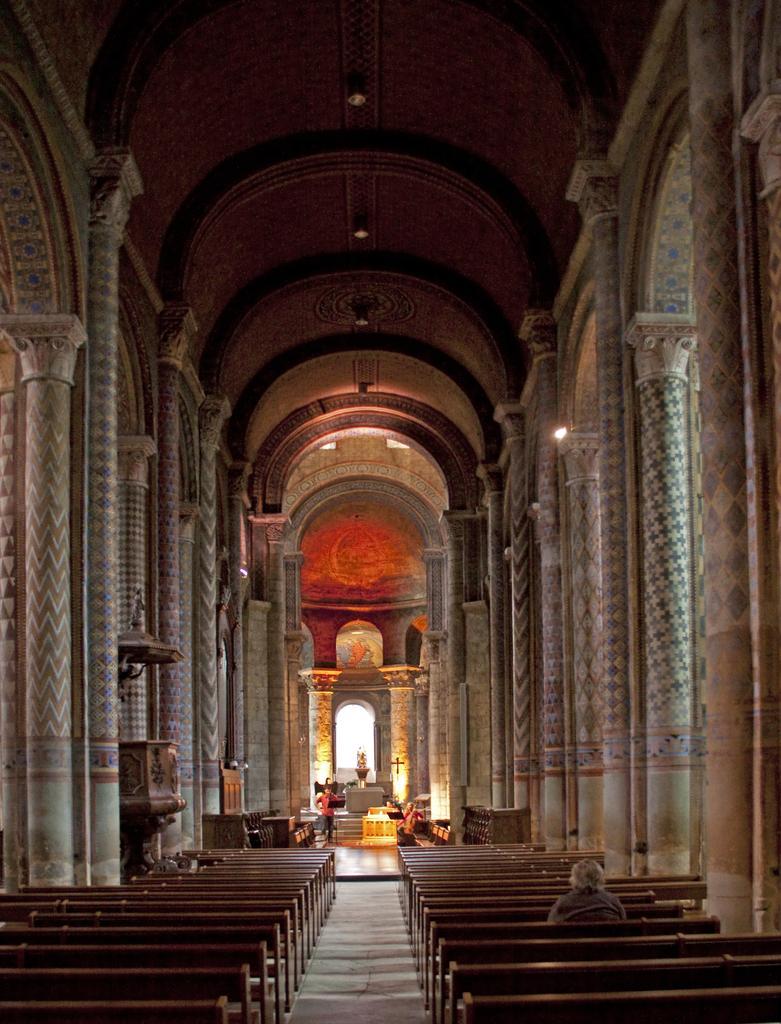Please provide a concise description of this image. In the image inside the room there are benches. There is a person sitting on the bench. And there are pillars and walls. In the background there are windows, crosses, podiums and some other things. 